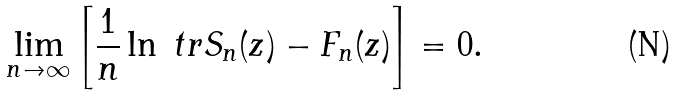<formula> <loc_0><loc_0><loc_500><loc_500>\lim _ { n \to \infty } \left [ \frac { 1 } { n } \ln \ t r S _ { n } ( z ) - F _ { n } ( z ) \right ] = 0 .</formula> 